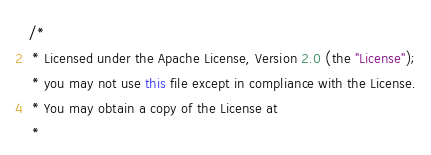<code> <loc_0><loc_0><loc_500><loc_500><_Java_>/*
 * Licensed under the Apache License, Version 2.0 (the "License");
 * you may not use this file except in compliance with the License.
 * You may obtain a copy of the License at
 *</code> 